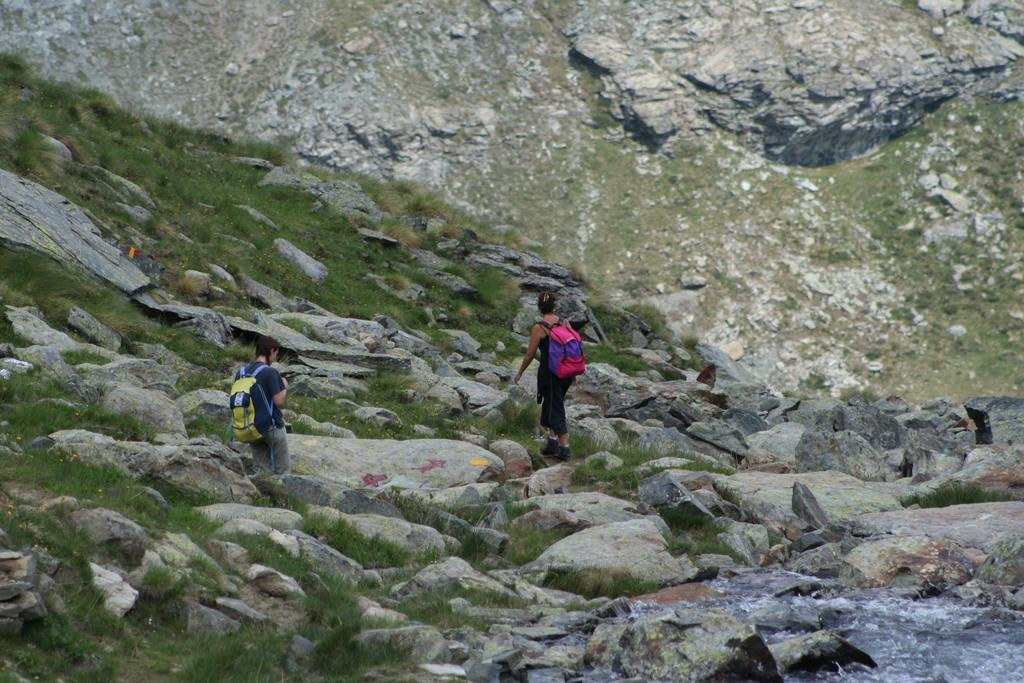How many people are in the image? There are two people in the image. What are the people carrying in the image? Both people are carrying bags on their shoulders. What type of natural feature can be seen in the background of the image? There is a hill visible in the background of the image. What else can be seen in the image besides the people and the hill? There are rocks in the image. What is the tendency of the hall in the image? There is no hall present in the image, so it is not possible to determine any tendencies. 